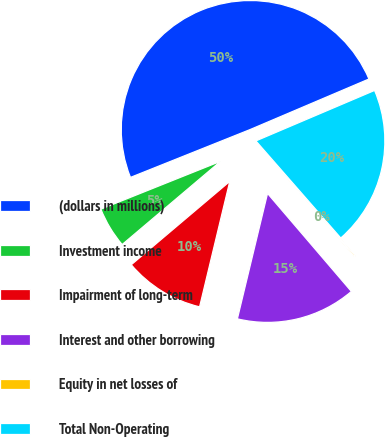<chart> <loc_0><loc_0><loc_500><loc_500><pie_chart><fcel>(dollars in millions)<fcel>Investment income<fcel>Impairment of long-term<fcel>Interest and other borrowing<fcel>Equity in net losses of<fcel>Total Non-Operating<nl><fcel>49.66%<fcel>5.12%<fcel>10.07%<fcel>15.02%<fcel>0.17%<fcel>19.97%<nl></chart> 